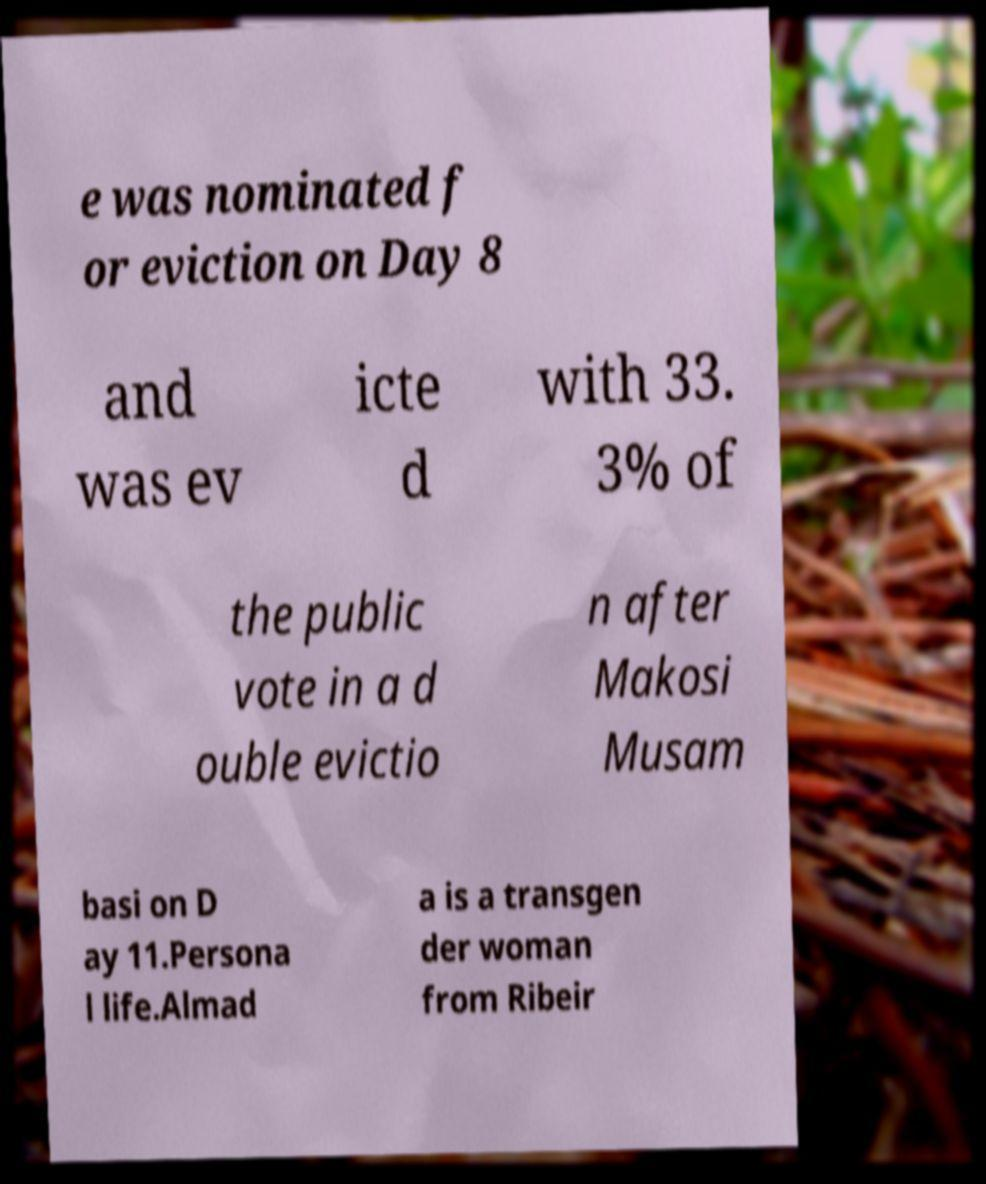Could you extract and type out the text from this image? e was nominated f or eviction on Day 8 and was ev icte d with 33. 3% of the public vote in a d ouble evictio n after Makosi Musam basi on D ay 11.Persona l life.Almad a is a transgen der woman from Ribeir 